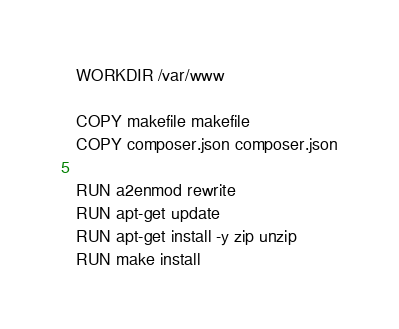<code> <loc_0><loc_0><loc_500><loc_500><_Dockerfile_>
WORKDIR /var/www

COPY makefile makefile
COPY composer.json composer.json

RUN a2enmod rewrite
RUN apt-get update
RUN apt-get install -y zip unzip
RUN make install
</code> 